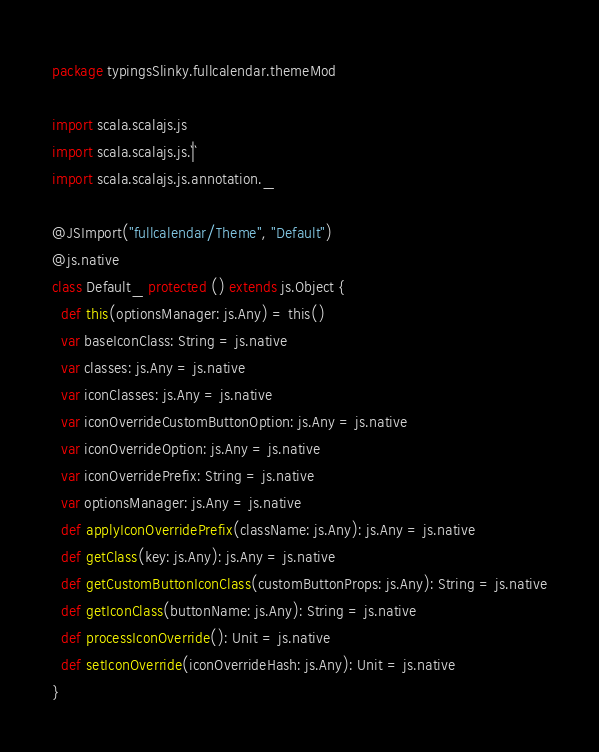<code> <loc_0><loc_0><loc_500><loc_500><_Scala_>package typingsSlinky.fullcalendar.themeMod

import scala.scalajs.js
import scala.scalajs.js.`|`
import scala.scalajs.js.annotation._

@JSImport("fullcalendar/Theme", "Default")
@js.native
class Default_ protected () extends js.Object {
  def this(optionsManager: js.Any) = this()
  var baseIconClass: String = js.native
  var classes: js.Any = js.native
  var iconClasses: js.Any = js.native
  var iconOverrideCustomButtonOption: js.Any = js.native
  var iconOverrideOption: js.Any = js.native
  var iconOverridePrefix: String = js.native
  var optionsManager: js.Any = js.native
  def applyIconOverridePrefix(className: js.Any): js.Any = js.native
  def getClass(key: js.Any): js.Any = js.native
  def getCustomButtonIconClass(customButtonProps: js.Any): String = js.native
  def getIconClass(buttonName: js.Any): String = js.native
  def processIconOverride(): Unit = js.native
  def setIconOverride(iconOverrideHash: js.Any): Unit = js.native
}

</code> 